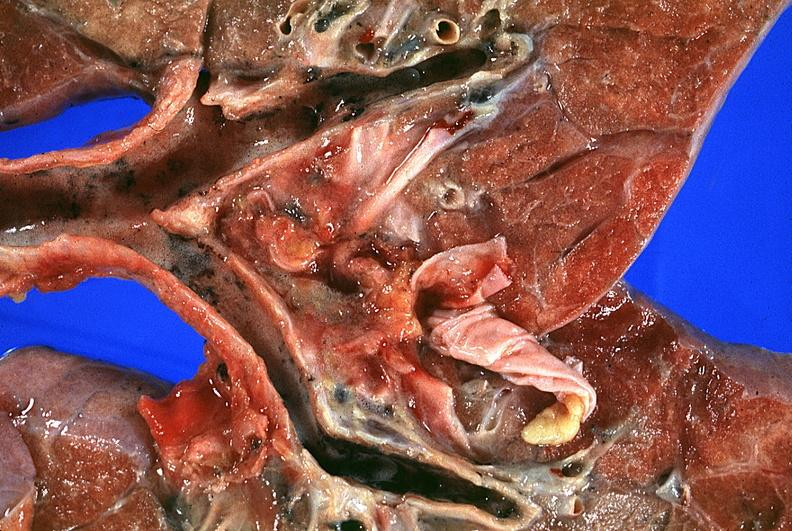does this image show lung?
Answer the question using a single word or phrase. Yes 